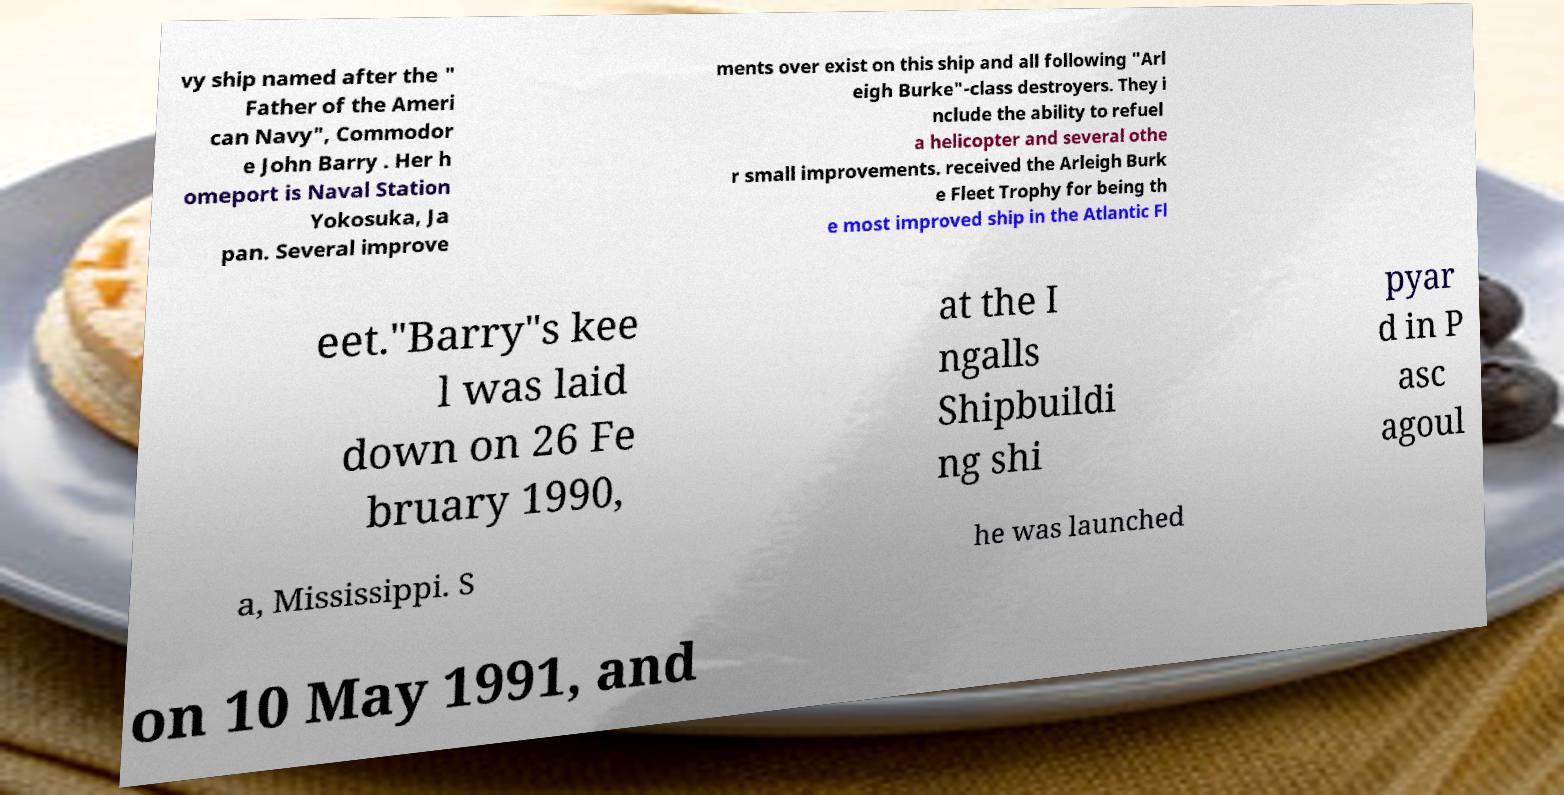Can you accurately transcribe the text from the provided image for me? vy ship named after the " Father of the Ameri can Navy", Commodor e John Barry . Her h omeport is Naval Station Yokosuka, Ja pan. Several improve ments over exist on this ship and all following "Arl eigh Burke"-class destroyers. They i nclude the ability to refuel a helicopter and several othe r small improvements. received the Arleigh Burk e Fleet Trophy for being th e most improved ship in the Atlantic Fl eet."Barry"s kee l was laid down on 26 Fe bruary 1990, at the I ngalls Shipbuildi ng shi pyar d in P asc agoul a, Mississippi. S he was launched on 10 May 1991, and 